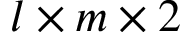<formula> <loc_0><loc_0><loc_500><loc_500>l \times m \times 2</formula> 